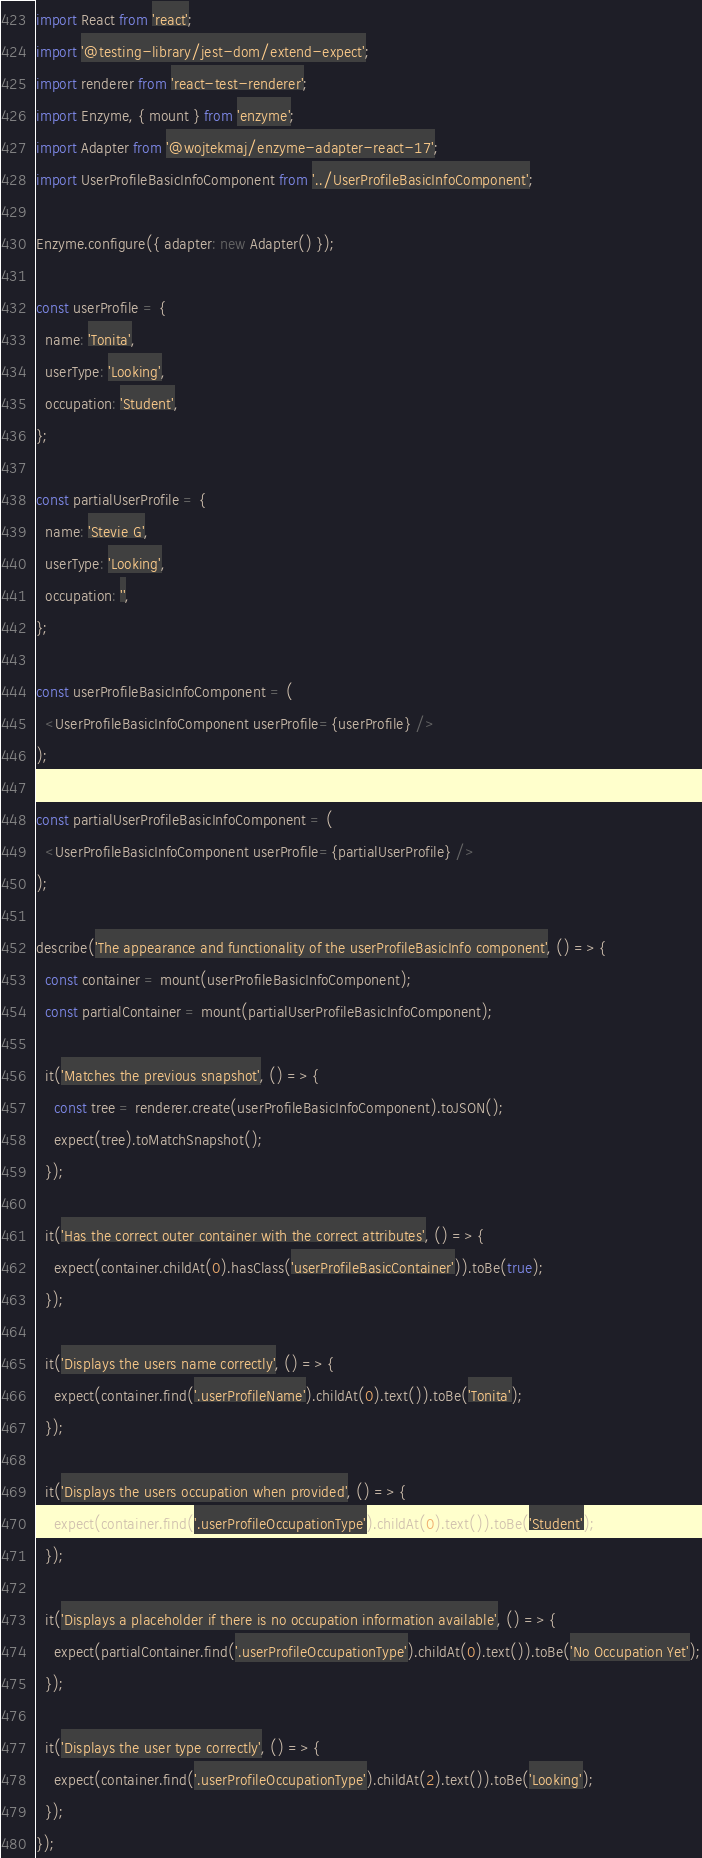<code> <loc_0><loc_0><loc_500><loc_500><_JavaScript_>import React from 'react';
import '@testing-library/jest-dom/extend-expect';
import renderer from 'react-test-renderer';
import Enzyme, { mount } from 'enzyme';
import Adapter from '@wojtekmaj/enzyme-adapter-react-17';
import UserProfileBasicInfoComponent from '../UserProfileBasicInfoComponent';

Enzyme.configure({ adapter: new Adapter() });

const userProfile = {
  name: 'Tonita',
  userType: 'Looking',
  occupation: 'Student',
};

const partialUserProfile = {
  name: 'Stevie G',
  userType: 'Looking',
  occupation: '',
};

const userProfileBasicInfoComponent = (
  <UserProfileBasicInfoComponent userProfile={userProfile} />
);

const partialUserProfileBasicInfoComponent = (
  <UserProfileBasicInfoComponent userProfile={partialUserProfile} />
);

describe('The appearance and functionality of the userProfileBasicInfo component', () => {
  const container = mount(userProfileBasicInfoComponent);
  const partialContainer = mount(partialUserProfileBasicInfoComponent);

  it('Matches the previous snapshot', () => {
    const tree = renderer.create(userProfileBasicInfoComponent).toJSON();
    expect(tree).toMatchSnapshot();
  });

  it('Has the correct outer container with the correct attributes', () => {
    expect(container.childAt(0).hasClass('userProfileBasicContainer')).toBe(true);
  });

  it('Displays the users name correctly', () => {
    expect(container.find('.userProfileName').childAt(0).text()).toBe('Tonita');
  });

  it('Displays the users occupation when provided', () => {
    expect(container.find('.userProfileOccupationType').childAt(0).text()).toBe('Student');
  });

  it('Displays a placeholder if there is no occupation information available', () => {
    expect(partialContainer.find('.userProfileOccupationType').childAt(0).text()).toBe('No Occupation Yet');
  });

  it('Displays the user type correctly', () => {
    expect(container.find('.userProfileOccupationType').childAt(2).text()).toBe('Looking');
  });
});
</code> 